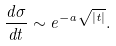Convert formula to latex. <formula><loc_0><loc_0><loc_500><loc_500>\frac { d \sigma } { d t } \sim e ^ { - a \sqrt { | t | } } .</formula> 